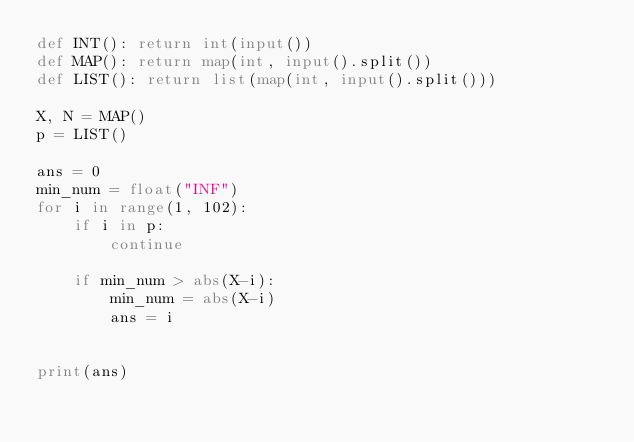<code> <loc_0><loc_0><loc_500><loc_500><_Python_>def INT(): return int(input())
def MAP(): return map(int, input().split())
def LIST(): return list(map(int, input().split()))

X, N = MAP()
p = LIST()

ans = 0
min_num = float("INF")
for i in range(1, 102):
    if i in p:
        continue
    
    if min_num > abs(X-i):
        min_num = abs(X-i)
        ans = i


print(ans)

</code> 